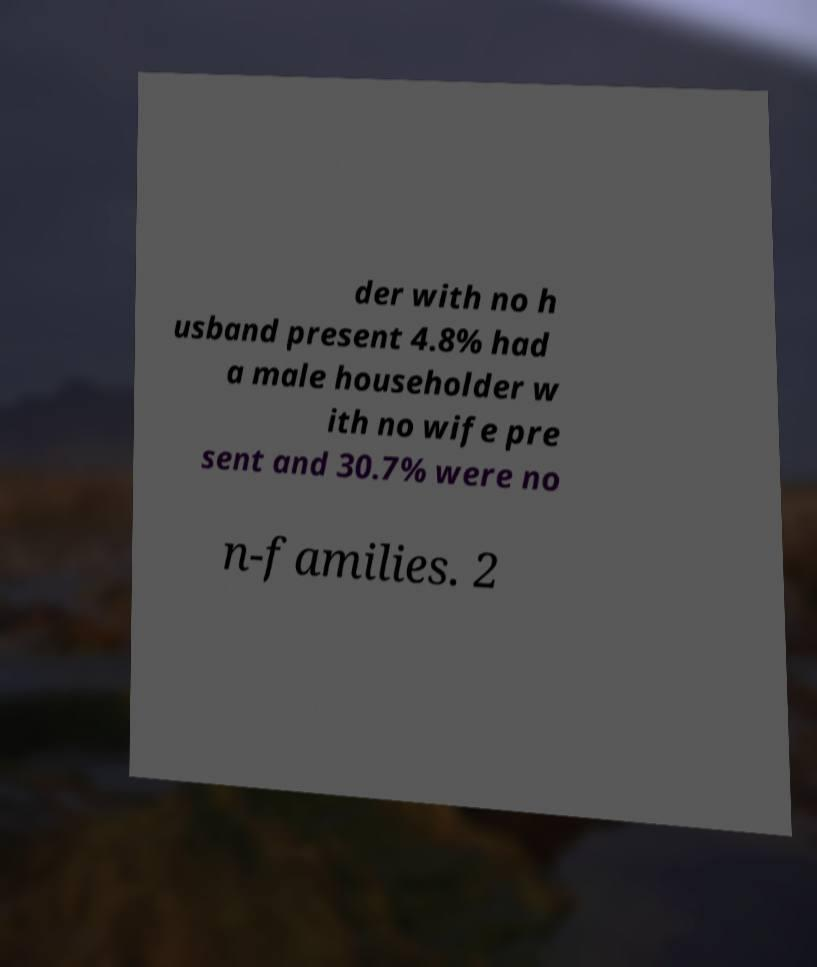Could you assist in decoding the text presented in this image and type it out clearly? der with no h usband present 4.8% had a male householder w ith no wife pre sent and 30.7% were no n-families. 2 